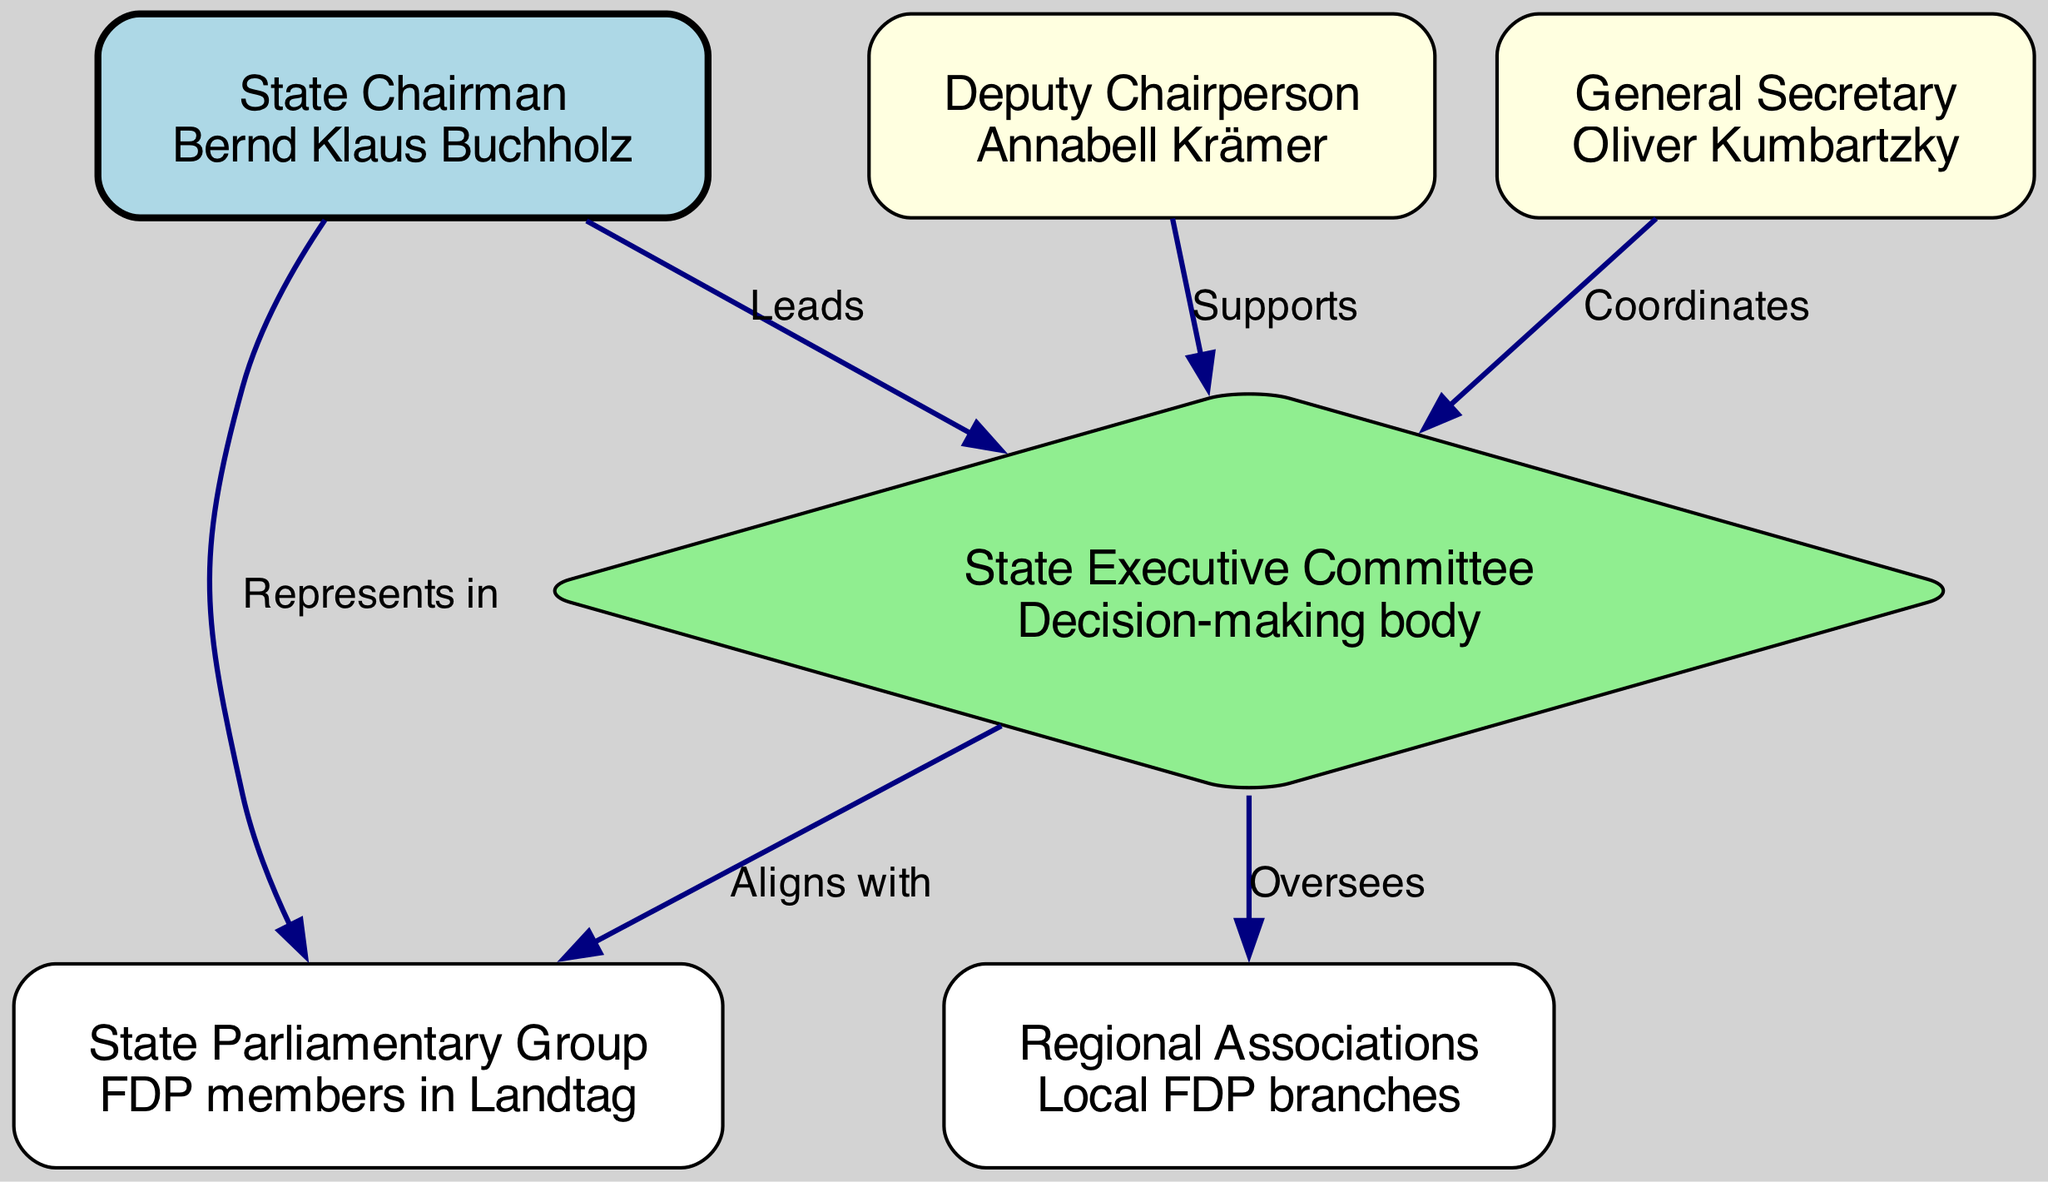What is the name of the State Chairman? The diagram identifies the State Chairman as Bernd Klaus Buchholz, represented as a node in the organizational structure labeled "State Chairman."
Answer: Bernd Klaus Buchholz Who supports the State Executive Committee? According to the edges in the diagram, Annabell Krämer, who is the Deputy Chairperson, has a labeled edge pointing to the "State Executive Committee" node indicating her supportive role.
Answer: Annabell Krämer How many nodes are present in the diagram? The diagram contains a total of six nodes, each representing different roles or entities within the organizational structure of the FDP in Schleswig-Holstein.
Answer: 6 What is the role of the State Executive Committee? In the diagram, the State Executive Committee is described as a "Decision-making body," providing information on its function within the organizational structure.
Answer: Decision-making body Which node represents FDP members in the Landtag? The diagram specifies that the "State Parliamentary Group" node represents the FDP members in the Landtag, clearly labeled within the diagram's structure.
Answer: State Parliamentary Group Who does the State Chairman represent in the Landtag? The diagram shows an edge labeled "Represents in" that leads from the State Chairman node, Bernd Klaus Buchholz, to the State Parliamentary Group node, indicating his representative role.
Answer: State Parliamentary Group How does the State Executive Committee align with the Regional Associations? The diagram illustrates that the State Executive Committee oversees the Regional Associations, indicated by an edge labeled "Oversees" connecting these two nodes.
Answer: Oversees What type of relationship exists between the General Secretary and the State Executive Committee? The edge connecting the General Secretary, Oliver Kumbartzky, to the State Executive Committee is labeled "Coordinates," indicating a collaborative relationship.
Answer: Coordinates What color represents the State Executive Committee in the diagram? The node for the State Executive Committee is filled with a light green color, distinguishing it from the other nodes within the organizational structure.
Answer: Light green 